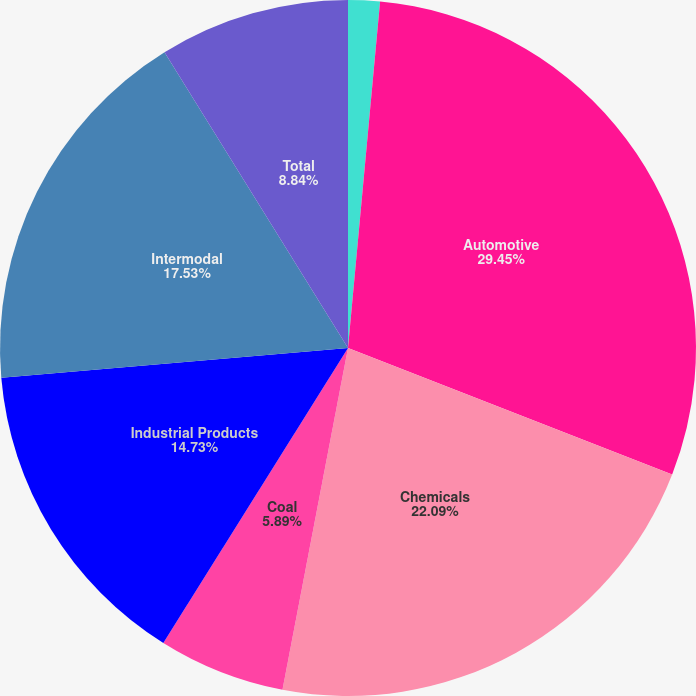Convert chart to OTSL. <chart><loc_0><loc_0><loc_500><loc_500><pie_chart><fcel>Agricultural<fcel>Automotive<fcel>Chemicals<fcel>Coal<fcel>Industrial Products<fcel>Intermodal<fcel>Total<nl><fcel>1.47%<fcel>29.46%<fcel>22.09%<fcel>5.89%<fcel>14.73%<fcel>17.53%<fcel>8.84%<nl></chart> 